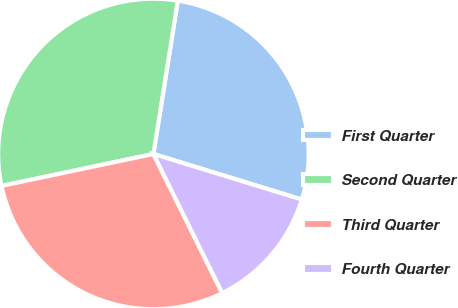Convert chart. <chart><loc_0><loc_0><loc_500><loc_500><pie_chart><fcel>First Quarter<fcel>Second Quarter<fcel>Third Quarter<fcel>Fourth Quarter<nl><fcel>27.23%<fcel>30.81%<fcel>29.01%<fcel>12.95%<nl></chart> 